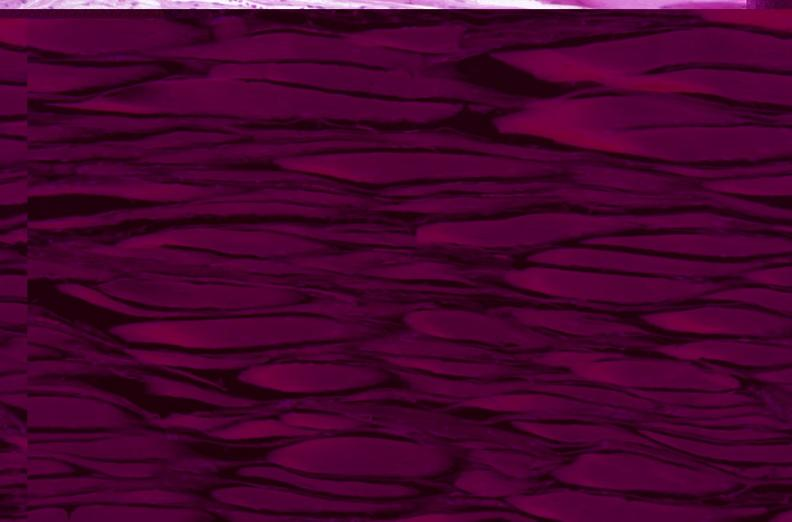does this image show skeletal muscle, atrophy due to immobilization cast?
Answer the question using a single word or phrase. Yes 